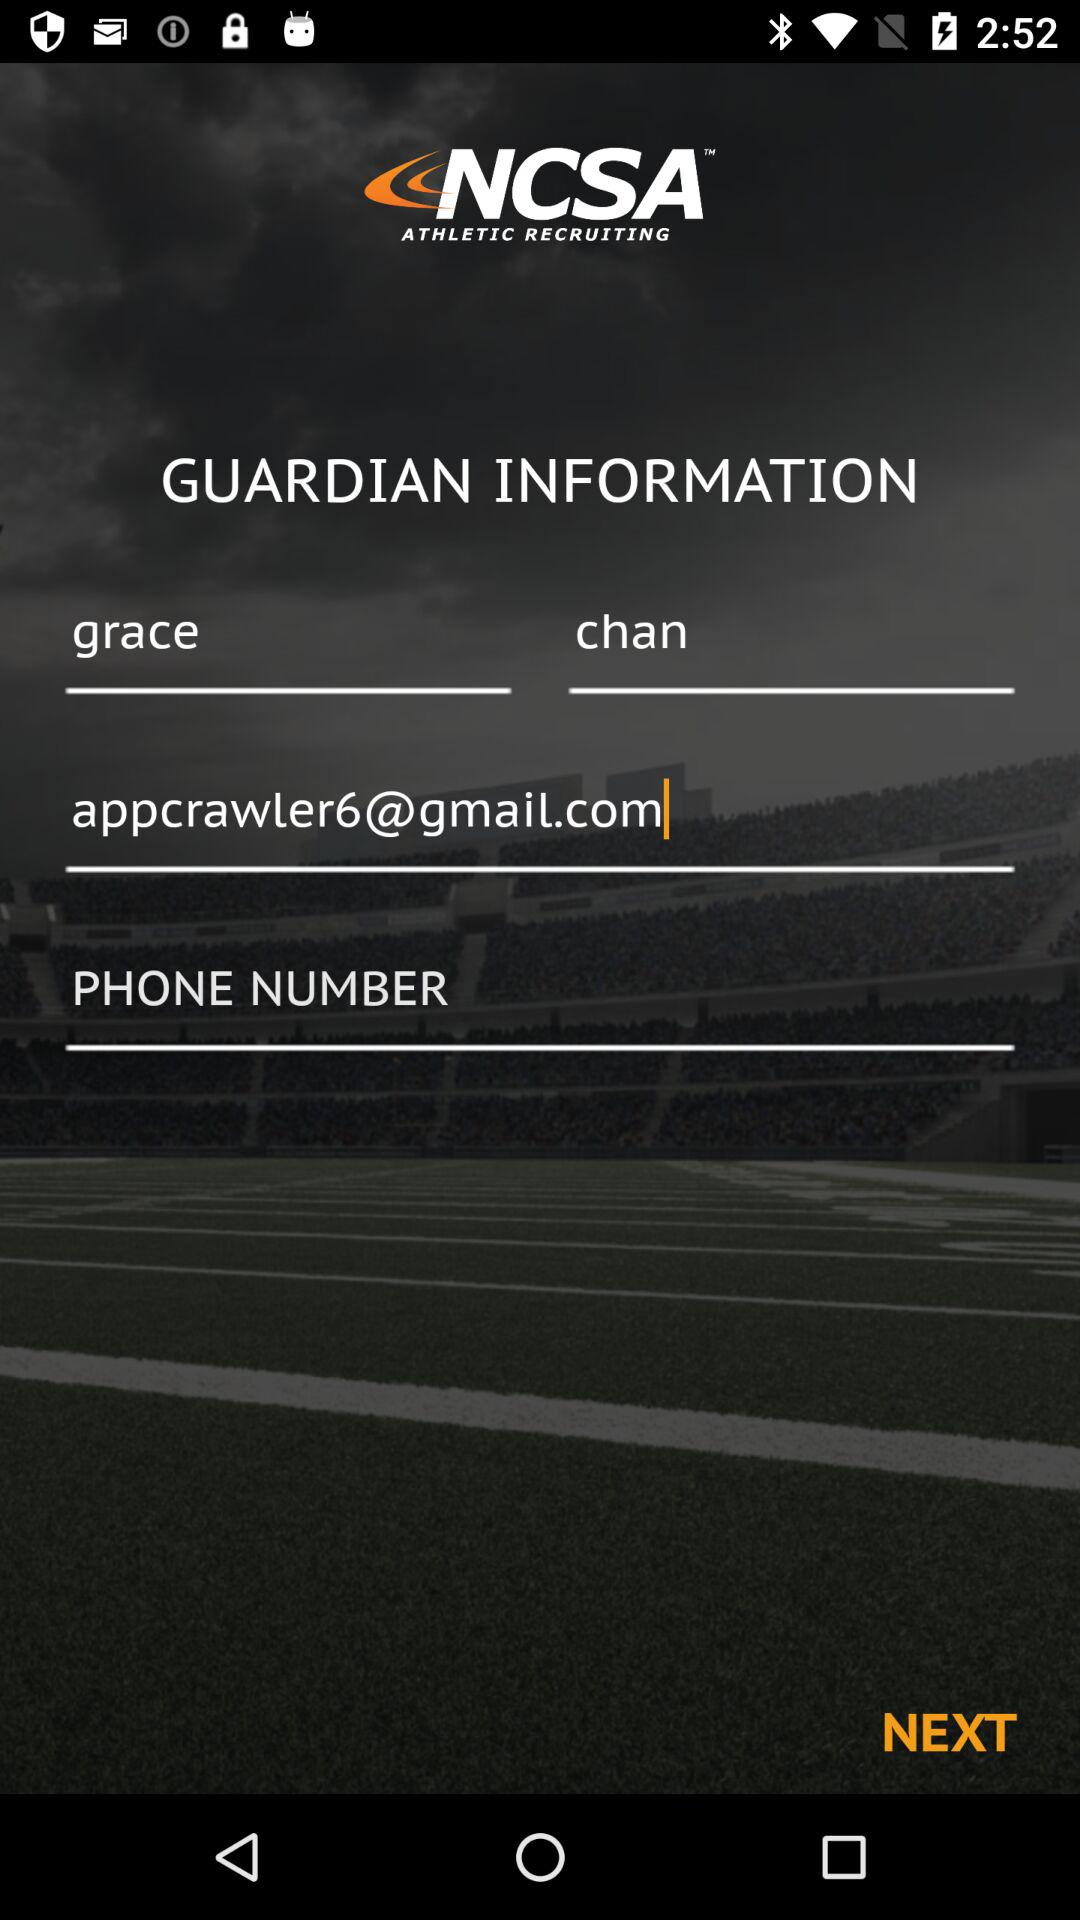What's the guardian name? The guardian name is Grace Chan. 